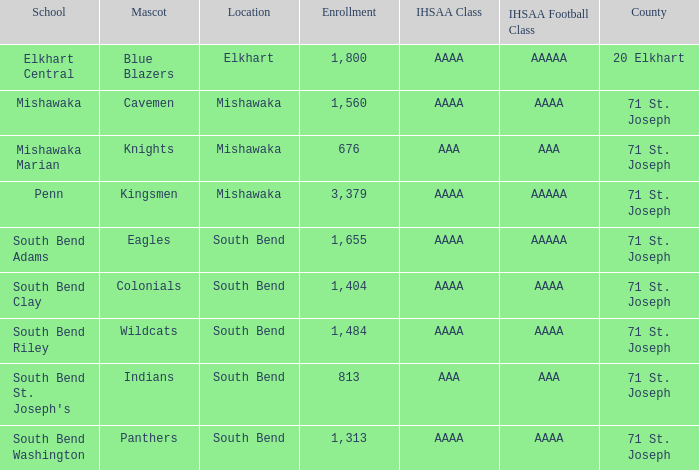What location has kingsmen as the mascot? Mishawaka. 